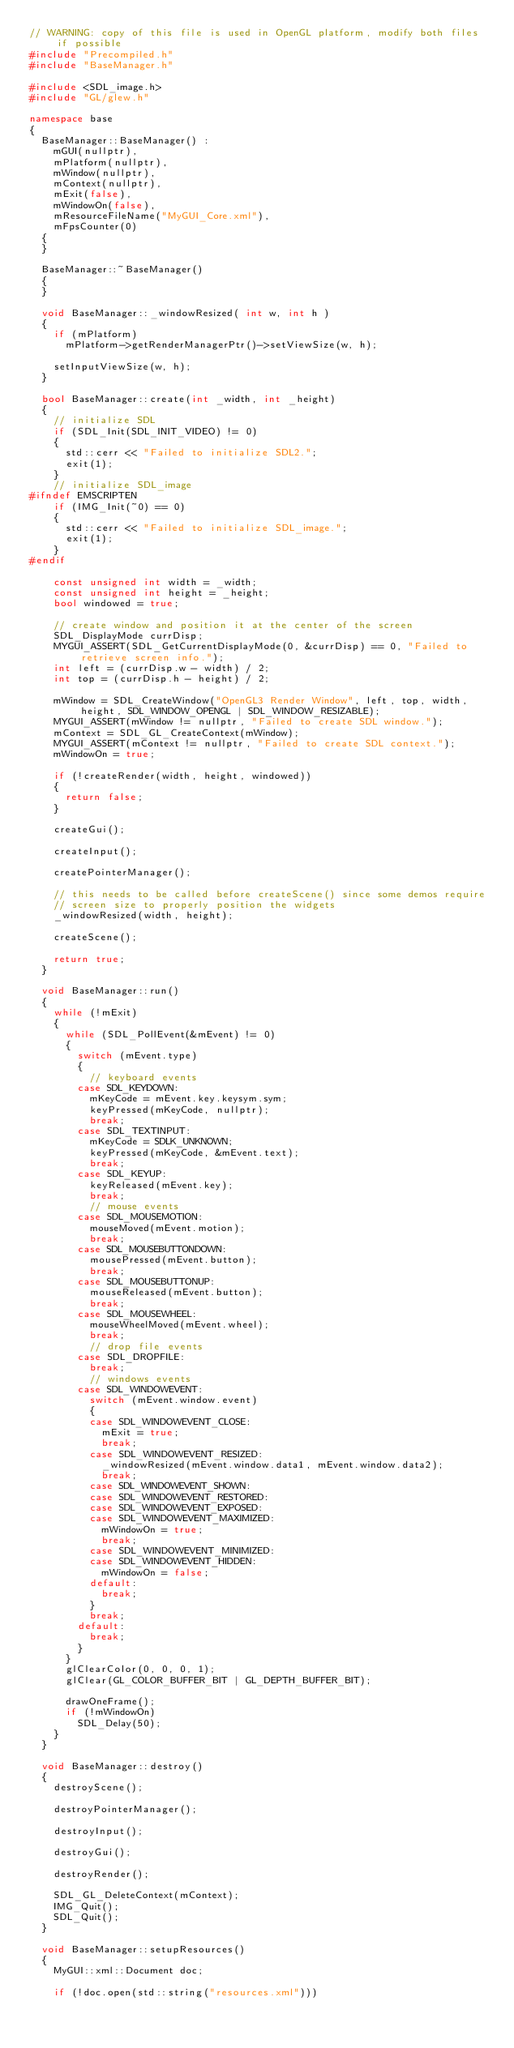<code> <loc_0><loc_0><loc_500><loc_500><_C++_>// WARNING: copy of this file is used in OpenGL platform, modify both files if possible
#include "Precompiled.h"
#include "BaseManager.h"

#include <SDL_image.h>
#include "GL/glew.h"

namespace base
{
	BaseManager::BaseManager() :
		mGUI(nullptr),
		mPlatform(nullptr),
		mWindow(nullptr),
		mContext(nullptr),
		mExit(false),
		mWindowOn(false),
		mResourceFileName("MyGUI_Core.xml"),
		mFpsCounter(0)
	{
	}

	BaseManager::~BaseManager()
	{
	}

	void BaseManager::_windowResized( int w, int h )
	{
		if (mPlatform)
			mPlatform->getRenderManagerPtr()->setViewSize(w, h);

		setInputViewSize(w, h);
	}

	bool BaseManager::create(int _width, int _height)
	{
		// initialize SDL
		if (SDL_Init(SDL_INIT_VIDEO) != 0)
		{
			std::cerr << "Failed to initialize SDL2.";
			exit(1);
		}
		// initialize SDL_image
#ifndef EMSCRIPTEN
		if (IMG_Init(~0) == 0)
		{
			std::cerr << "Failed to initialize SDL_image.";
			exit(1);
		}
#endif

		const unsigned int width = _width;
		const unsigned int height = _height;
		bool windowed = true;

		// create window and position it at the center of the screen
		SDL_DisplayMode currDisp;
		MYGUI_ASSERT(SDL_GetCurrentDisplayMode(0, &currDisp) == 0, "Failed to retrieve screen info.");
		int left = (currDisp.w - width) / 2;
		int top = (currDisp.h - height) / 2;

		mWindow = SDL_CreateWindow("OpenGL3 Render Window", left, top, width, height, SDL_WINDOW_OPENGL | SDL_WINDOW_RESIZABLE);
		MYGUI_ASSERT(mWindow != nullptr, "Failed to create SDL window.");
		mContext = SDL_GL_CreateContext(mWindow);
		MYGUI_ASSERT(mContext != nullptr, "Failed to create SDL context.");
		mWindowOn = true;

		if (!createRender(width, height, windowed))
		{
			return false;
		}

		createGui();

		createInput();

		createPointerManager();

		// this needs to be called before createScene() since some demos require
		// screen size to properly position the widgets
		_windowResized(width, height);

		createScene();

		return true;
	}

	void BaseManager::run()
	{
		while (!mExit)
		{
			while (SDL_PollEvent(&mEvent) != 0)
			{
				switch (mEvent.type)
				{
					// keyboard events
				case SDL_KEYDOWN:
					mKeyCode = mEvent.key.keysym.sym;
					keyPressed(mKeyCode, nullptr);
					break;
				case SDL_TEXTINPUT:
					mKeyCode = SDLK_UNKNOWN;
					keyPressed(mKeyCode, &mEvent.text);
					break;
				case SDL_KEYUP:
					keyReleased(mEvent.key);
					break;
					// mouse events
				case SDL_MOUSEMOTION:
					mouseMoved(mEvent.motion);
					break;
				case SDL_MOUSEBUTTONDOWN:
					mousePressed(mEvent.button);
					break;
				case SDL_MOUSEBUTTONUP:
					mouseReleased(mEvent.button);
					break;
				case SDL_MOUSEWHEEL:
					mouseWheelMoved(mEvent.wheel);
					break;
					// drop file events
				case SDL_DROPFILE:
					break;
					// windows events
				case SDL_WINDOWEVENT:
					switch (mEvent.window.event)
					{
					case SDL_WINDOWEVENT_CLOSE:
						mExit = true;
						break;
					case SDL_WINDOWEVENT_RESIZED:
						_windowResized(mEvent.window.data1, mEvent.window.data2);
						break;
					case SDL_WINDOWEVENT_SHOWN:
					case SDL_WINDOWEVENT_RESTORED:
					case SDL_WINDOWEVENT_EXPOSED:
					case SDL_WINDOWEVENT_MAXIMIZED:
						mWindowOn = true;
						break;
					case SDL_WINDOWEVENT_MINIMIZED:
					case SDL_WINDOWEVENT_HIDDEN:
						mWindowOn = false;
					default:
						break;
					}
					break;
				default:
					break;
				}
			}
			glClearColor(0, 0, 0, 1);
			glClear(GL_COLOR_BUFFER_BIT | GL_DEPTH_BUFFER_BIT);

			drawOneFrame();
			if (!mWindowOn)
				SDL_Delay(50);
		}
	}

	void BaseManager::destroy()
	{
		destroyScene();

		destroyPointerManager();

		destroyInput();

		destroyGui();

		destroyRender();

		SDL_GL_DeleteContext(mContext);
		IMG_Quit();
		SDL_Quit();
	}

	void BaseManager::setupResources()
	{
		MyGUI::xml::Document doc;

		if (!doc.open(std::string("resources.xml")))</code> 